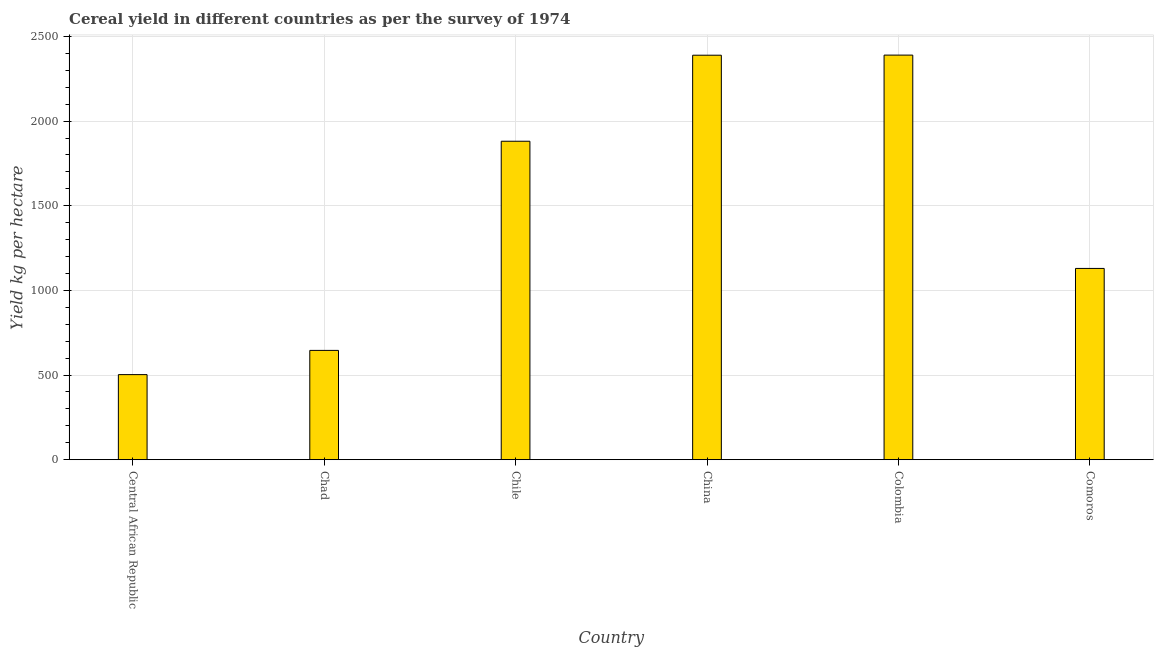Does the graph contain any zero values?
Ensure brevity in your answer.  No. Does the graph contain grids?
Your answer should be compact. Yes. What is the title of the graph?
Your answer should be very brief. Cereal yield in different countries as per the survey of 1974. What is the label or title of the X-axis?
Keep it short and to the point. Country. What is the label or title of the Y-axis?
Your answer should be compact. Yield kg per hectare. What is the cereal yield in Central African Republic?
Provide a short and direct response. 502.56. Across all countries, what is the maximum cereal yield?
Offer a very short reply. 2389.84. Across all countries, what is the minimum cereal yield?
Keep it short and to the point. 502.56. In which country was the cereal yield maximum?
Keep it short and to the point. Colombia. In which country was the cereal yield minimum?
Offer a very short reply. Central African Republic. What is the sum of the cereal yield?
Your response must be concise. 8938. What is the difference between the cereal yield in Central African Republic and Colombia?
Offer a very short reply. -1887.28. What is the average cereal yield per country?
Provide a succinct answer. 1489.67. What is the median cereal yield?
Your answer should be compact. 1505.39. In how many countries, is the cereal yield greater than 500 kg per hectare?
Your answer should be compact. 6. What is the ratio of the cereal yield in Chile to that in Comoros?
Your answer should be compact. 1.67. What is the difference between the highest and the second highest cereal yield?
Provide a short and direct response. 0.63. What is the difference between the highest and the lowest cereal yield?
Make the answer very short. 1887.28. How many bars are there?
Offer a terse response. 6. Are all the bars in the graph horizontal?
Give a very brief answer. No. How many countries are there in the graph?
Make the answer very short. 6. What is the Yield kg per hectare of Central African Republic?
Keep it short and to the point. 502.56. What is the Yield kg per hectare of Chad?
Offer a very short reply. 645.61. What is the Yield kg per hectare of Chile?
Your answer should be very brief. 1881.02. What is the Yield kg per hectare of China?
Your response must be concise. 2389.21. What is the Yield kg per hectare in Colombia?
Offer a terse response. 2389.84. What is the Yield kg per hectare of Comoros?
Your response must be concise. 1129.77. What is the difference between the Yield kg per hectare in Central African Republic and Chad?
Make the answer very short. -143.05. What is the difference between the Yield kg per hectare in Central African Republic and Chile?
Make the answer very short. -1378.46. What is the difference between the Yield kg per hectare in Central African Republic and China?
Your response must be concise. -1886.65. What is the difference between the Yield kg per hectare in Central African Republic and Colombia?
Ensure brevity in your answer.  -1887.28. What is the difference between the Yield kg per hectare in Central African Republic and Comoros?
Give a very brief answer. -627.21. What is the difference between the Yield kg per hectare in Chad and Chile?
Ensure brevity in your answer.  -1235.41. What is the difference between the Yield kg per hectare in Chad and China?
Ensure brevity in your answer.  -1743.6. What is the difference between the Yield kg per hectare in Chad and Colombia?
Ensure brevity in your answer.  -1744.23. What is the difference between the Yield kg per hectare in Chad and Comoros?
Offer a very short reply. -484.16. What is the difference between the Yield kg per hectare in Chile and China?
Make the answer very short. -508.19. What is the difference between the Yield kg per hectare in Chile and Colombia?
Your answer should be very brief. -508.82. What is the difference between the Yield kg per hectare in Chile and Comoros?
Give a very brief answer. 751.25. What is the difference between the Yield kg per hectare in China and Colombia?
Provide a short and direct response. -0.63. What is the difference between the Yield kg per hectare in China and Comoros?
Your answer should be very brief. 1259.44. What is the difference between the Yield kg per hectare in Colombia and Comoros?
Ensure brevity in your answer.  1260.07. What is the ratio of the Yield kg per hectare in Central African Republic to that in Chad?
Make the answer very short. 0.78. What is the ratio of the Yield kg per hectare in Central African Republic to that in Chile?
Make the answer very short. 0.27. What is the ratio of the Yield kg per hectare in Central African Republic to that in China?
Give a very brief answer. 0.21. What is the ratio of the Yield kg per hectare in Central African Republic to that in Colombia?
Keep it short and to the point. 0.21. What is the ratio of the Yield kg per hectare in Central African Republic to that in Comoros?
Provide a short and direct response. 0.45. What is the ratio of the Yield kg per hectare in Chad to that in Chile?
Make the answer very short. 0.34. What is the ratio of the Yield kg per hectare in Chad to that in China?
Make the answer very short. 0.27. What is the ratio of the Yield kg per hectare in Chad to that in Colombia?
Give a very brief answer. 0.27. What is the ratio of the Yield kg per hectare in Chad to that in Comoros?
Your answer should be compact. 0.57. What is the ratio of the Yield kg per hectare in Chile to that in China?
Your answer should be very brief. 0.79. What is the ratio of the Yield kg per hectare in Chile to that in Colombia?
Provide a short and direct response. 0.79. What is the ratio of the Yield kg per hectare in Chile to that in Comoros?
Make the answer very short. 1.67. What is the ratio of the Yield kg per hectare in China to that in Colombia?
Ensure brevity in your answer.  1. What is the ratio of the Yield kg per hectare in China to that in Comoros?
Offer a very short reply. 2.12. What is the ratio of the Yield kg per hectare in Colombia to that in Comoros?
Your answer should be compact. 2.12. 